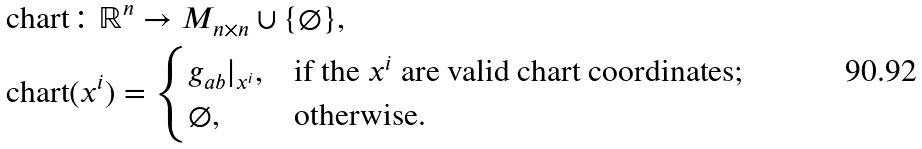<formula> <loc_0><loc_0><loc_500><loc_500>& \text {chart} \colon \mathbb { R } ^ { n } \to M _ { n \times n } \cup \{ \varnothing \} , \\ & \text {chart} ( x ^ { i } ) = \begin{cases} g _ { a b } | _ { x ^ { i } } , & \text {if the $x^{i}$ are valid chart coordinates;} \\ \varnothing , & \text {otherwise.} \end{cases}</formula> 